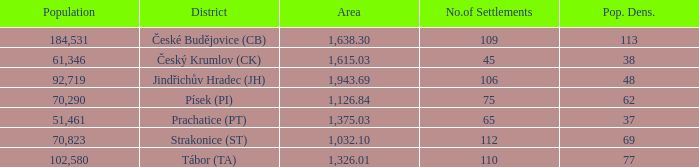What is the population density of the area with a population larger than 92,719? 2.0. 